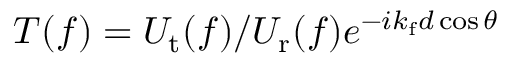<formula> <loc_0><loc_0><loc_500><loc_500>T ( f ) = U _ { t } ( f ) / U _ { r } ( f ) e ^ { - i k _ { f } d \cos \theta }</formula> 